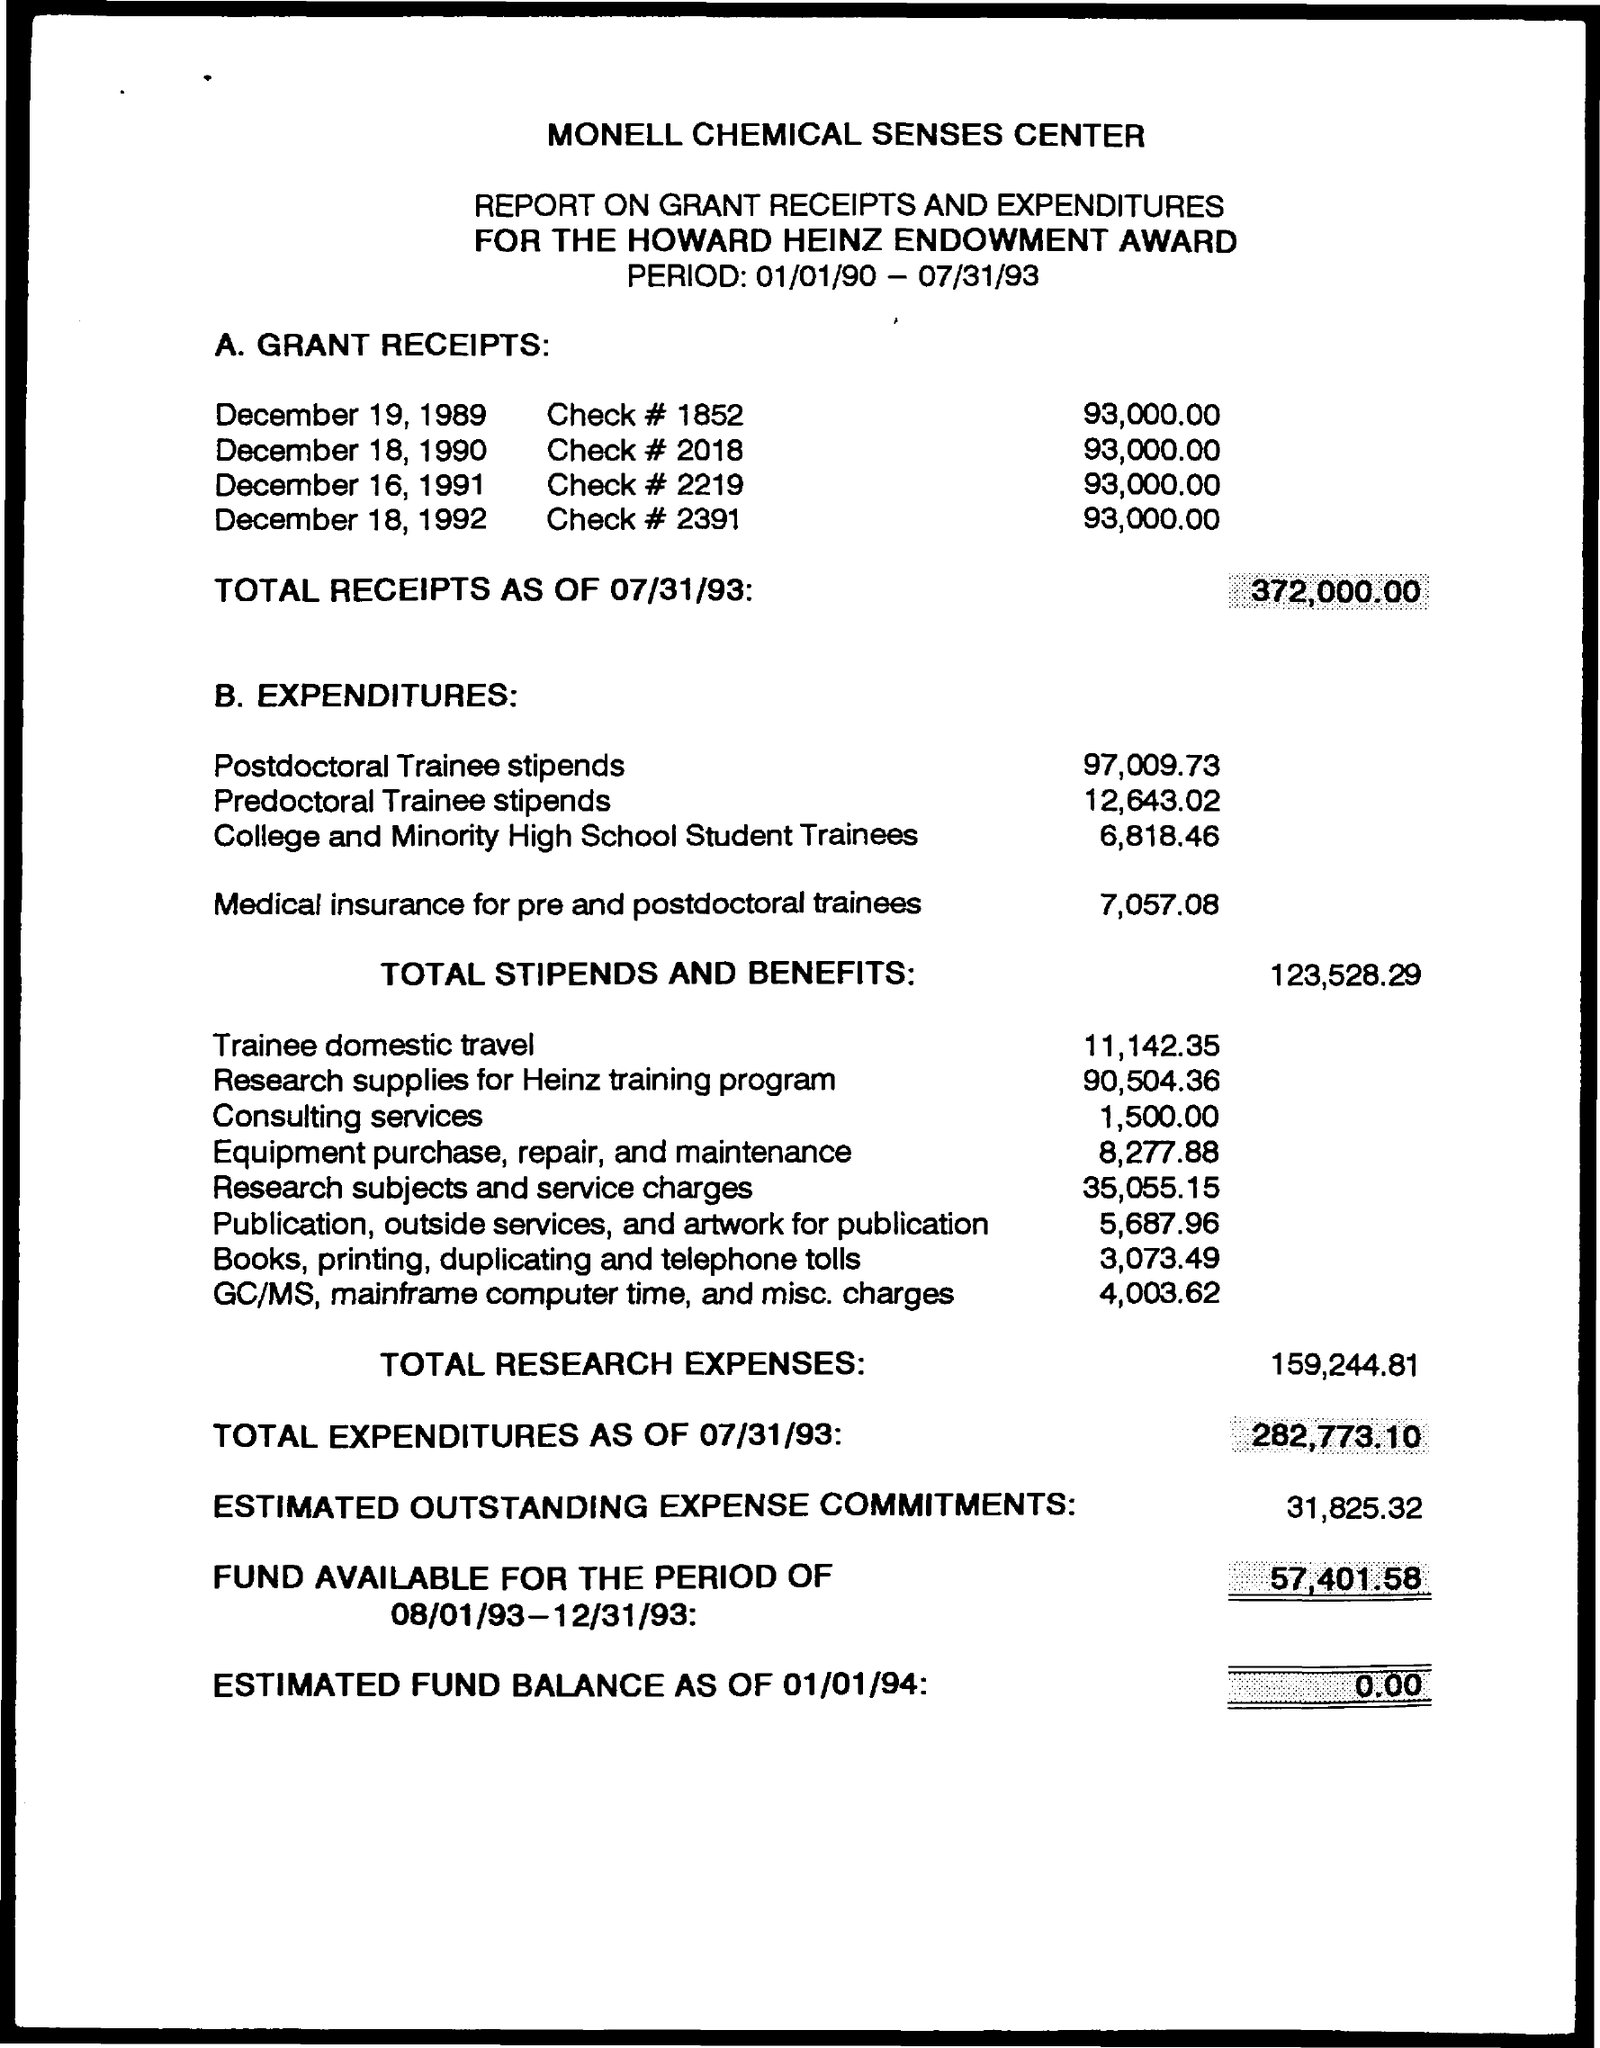How much total recepits ?
Provide a short and direct response. 372,000.00. What is the Check number on December  19, 1989 ?
Provide a succinct answer. 1852. How much Total Stipends and Benefits ?
Your response must be concise. 123,528.29. How much total research expenses ?
Provide a short and direct response. 159,244.81. 